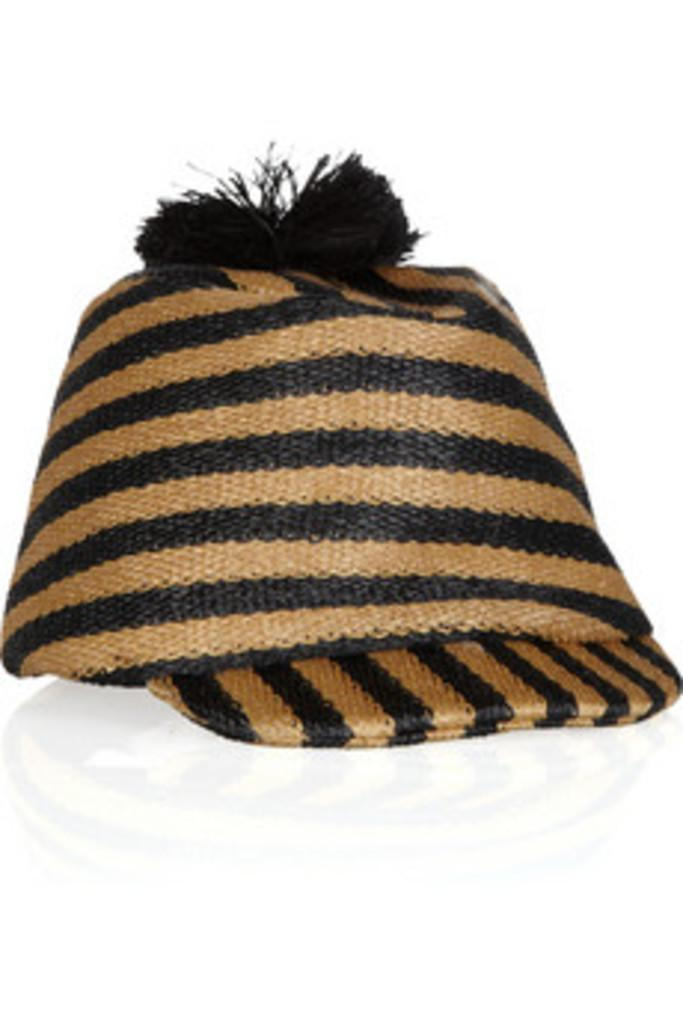What type of hat is in the image? There is a brown and black hat in the image. What color is the surface the hat is placed on? The hat is placed on a white surface. Where is the drawer located in the image? There is no drawer present in the image; it only features a brown and black hat placed on a white surface. 